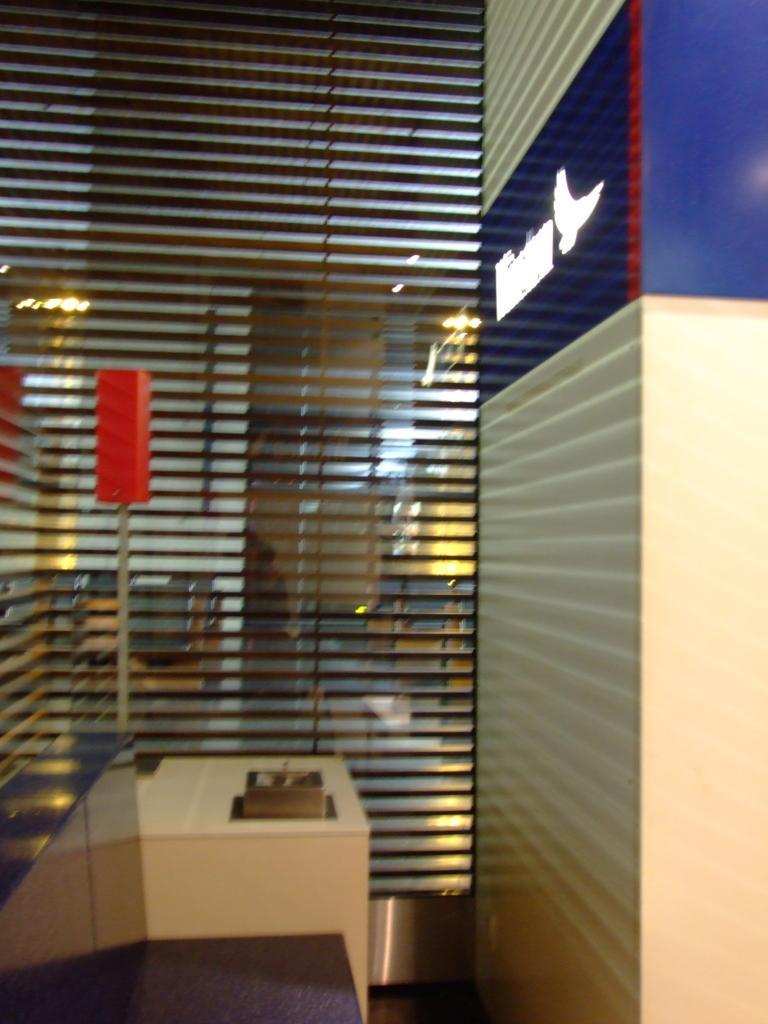Can you describe this image briefly? In this picture I see the wall on the right side of this image and I see cream color thing in front and I see a glass through which I see a room and I see the lights on the top and I see the wall. 